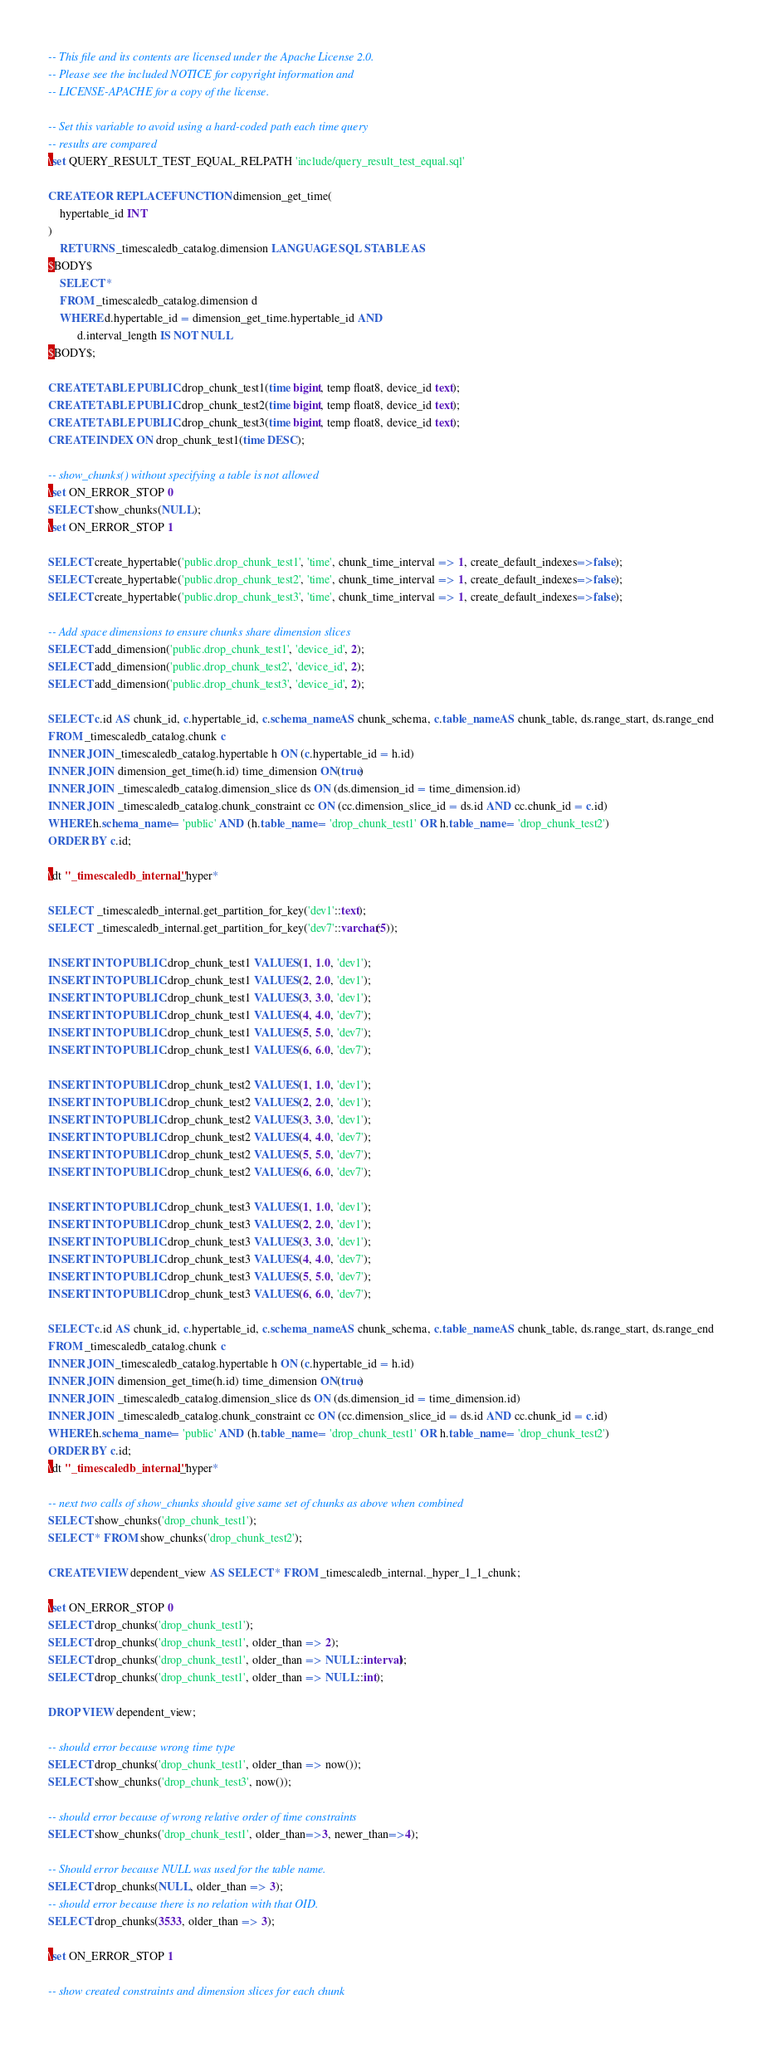<code> <loc_0><loc_0><loc_500><loc_500><_SQL_>-- This file and its contents are licensed under the Apache License 2.0.
-- Please see the included NOTICE for copyright information and
-- LICENSE-APACHE for a copy of the license.

-- Set this variable to avoid using a hard-coded path each time query
-- results are compared
\set QUERY_RESULT_TEST_EQUAL_RELPATH 'include/query_result_test_equal.sql'

CREATE OR REPLACE FUNCTION dimension_get_time(
    hypertable_id INT
)
    RETURNS _timescaledb_catalog.dimension LANGUAGE SQL STABLE AS
$BODY$
    SELECT *
    FROM _timescaledb_catalog.dimension d
    WHERE d.hypertable_id = dimension_get_time.hypertable_id AND
          d.interval_length IS NOT NULL
$BODY$;

CREATE TABLE PUBLIC.drop_chunk_test1(time bigint, temp float8, device_id text);
CREATE TABLE PUBLIC.drop_chunk_test2(time bigint, temp float8, device_id text);
CREATE TABLE PUBLIC.drop_chunk_test3(time bigint, temp float8, device_id text);
CREATE INDEX ON drop_chunk_test1(time DESC);

-- show_chunks() without specifying a table is not allowed
\set ON_ERROR_STOP 0
SELECT show_chunks(NULL);
\set ON_ERROR_STOP 1

SELECT create_hypertable('public.drop_chunk_test1', 'time', chunk_time_interval => 1, create_default_indexes=>false);
SELECT create_hypertable('public.drop_chunk_test2', 'time', chunk_time_interval => 1, create_default_indexes=>false);
SELECT create_hypertable('public.drop_chunk_test3', 'time', chunk_time_interval => 1, create_default_indexes=>false);

-- Add space dimensions to ensure chunks share dimension slices
SELECT add_dimension('public.drop_chunk_test1', 'device_id', 2);
SELECT add_dimension('public.drop_chunk_test2', 'device_id', 2);
SELECT add_dimension('public.drop_chunk_test3', 'device_id', 2);

SELECT c.id AS chunk_id, c.hypertable_id, c.schema_name AS chunk_schema, c.table_name AS chunk_table, ds.range_start, ds.range_end
FROM _timescaledb_catalog.chunk c
INNER JOIN _timescaledb_catalog.hypertable h ON (c.hypertable_id = h.id)
INNER JOIN  dimension_get_time(h.id) time_dimension ON(true)
INNER JOIN  _timescaledb_catalog.dimension_slice ds ON (ds.dimension_id = time_dimension.id)
INNER JOIN  _timescaledb_catalog.chunk_constraint cc ON (cc.dimension_slice_id = ds.id AND cc.chunk_id = c.id)
WHERE h.schema_name = 'public' AND (h.table_name = 'drop_chunk_test1' OR h.table_name = 'drop_chunk_test2')
ORDER BY c.id;

\dt "_timescaledb_internal"._hyper*

SELECT  _timescaledb_internal.get_partition_for_key('dev1'::text);
SELECT  _timescaledb_internal.get_partition_for_key('dev7'::varchar(5));

INSERT INTO PUBLIC.drop_chunk_test1 VALUES(1, 1.0, 'dev1');
INSERT INTO PUBLIC.drop_chunk_test1 VALUES(2, 2.0, 'dev1');
INSERT INTO PUBLIC.drop_chunk_test1 VALUES(3, 3.0, 'dev1');
INSERT INTO PUBLIC.drop_chunk_test1 VALUES(4, 4.0, 'dev7');
INSERT INTO PUBLIC.drop_chunk_test1 VALUES(5, 5.0, 'dev7');
INSERT INTO PUBLIC.drop_chunk_test1 VALUES(6, 6.0, 'dev7');

INSERT INTO PUBLIC.drop_chunk_test2 VALUES(1, 1.0, 'dev1');
INSERT INTO PUBLIC.drop_chunk_test2 VALUES(2, 2.0, 'dev1');
INSERT INTO PUBLIC.drop_chunk_test2 VALUES(3, 3.0, 'dev1');
INSERT INTO PUBLIC.drop_chunk_test2 VALUES(4, 4.0, 'dev7');
INSERT INTO PUBLIC.drop_chunk_test2 VALUES(5, 5.0, 'dev7');
INSERT INTO PUBLIC.drop_chunk_test2 VALUES(6, 6.0, 'dev7');

INSERT INTO PUBLIC.drop_chunk_test3 VALUES(1, 1.0, 'dev1');
INSERT INTO PUBLIC.drop_chunk_test3 VALUES(2, 2.0, 'dev1');
INSERT INTO PUBLIC.drop_chunk_test3 VALUES(3, 3.0, 'dev1');
INSERT INTO PUBLIC.drop_chunk_test3 VALUES(4, 4.0, 'dev7');
INSERT INTO PUBLIC.drop_chunk_test3 VALUES(5, 5.0, 'dev7');
INSERT INTO PUBLIC.drop_chunk_test3 VALUES(6, 6.0, 'dev7');

SELECT c.id AS chunk_id, c.hypertable_id, c.schema_name AS chunk_schema, c.table_name AS chunk_table, ds.range_start, ds.range_end
FROM _timescaledb_catalog.chunk c
INNER JOIN _timescaledb_catalog.hypertable h ON (c.hypertable_id = h.id)
INNER JOIN  dimension_get_time(h.id) time_dimension ON(true)
INNER JOIN  _timescaledb_catalog.dimension_slice ds ON (ds.dimension_id = time_dimension.id)
INNER JOIN  _timescaledb_catalog.chunk_constraint cc ON (cc.dimension_slice_id = ds.id AND cc.chunk_id = c.id)
WHERE h.schema_name = 'public' AND (h.table_name = 'drop_chunk_test1' OR h.table_name = 'drop_chunk_test2')
ORDER BY c.id;
\dt "_timescaledb_internal"._hyper*

-- next two calls of show_chunks should give same set of chunks as above when combined
SELECT show_chunks('drop_chunk_test1');
SELECT * FROM show_chunks('drop_chunk_test2');

CREATE VIEW dependent_view AS SELECT * FROM _timescaledb_internal._hyper_1_1_chunk;

\set ON_ERROR_STOP 0
SELECT drop_chunks('drop_chunk_test1');
SELECT drop_chunks('drop_chunk_test1', older_than => 2);
SELECT drop_chunks('drop_chunk_test1', older_than => NULL::interval);
SELECT drop_chunks('drop_chunk_test1', older_than => NULL::int);

DROP VIEW dependent_view;

-- should error because wrong time type
SELECT drop_chunks('drop_chunk_test1', older_than => now());
SELECT show_chunks('drop_chunk_test3', now());

-- should error because of wrong relative order of time constraints
SELECT show_chunks('drop_chunk_test1', older_than=>3, newer_than=>4);

-- Should error because NULL was used for the table name.
SELECT drop_chunks(NULL, older_than => 3);
-- should error because there is no relation with that OID.
SELECT drop_chunks(3533, older_than => 3);

\set ON_ERROR_STOP 1

-- show created constraints and dimension slices for each chunk</code> 